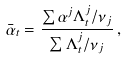<formula> <loc_0><loc_0><loc_500><loc_500>\bar { \alpha } _ { t } = \frac { \sum \alpha ^ { j } \Lambda ^ { j } _ { t } / \nu _ { j } } { \sum \Lambda ^ { j } _ { t } / \nu _ { j } } \, ,</formula> 